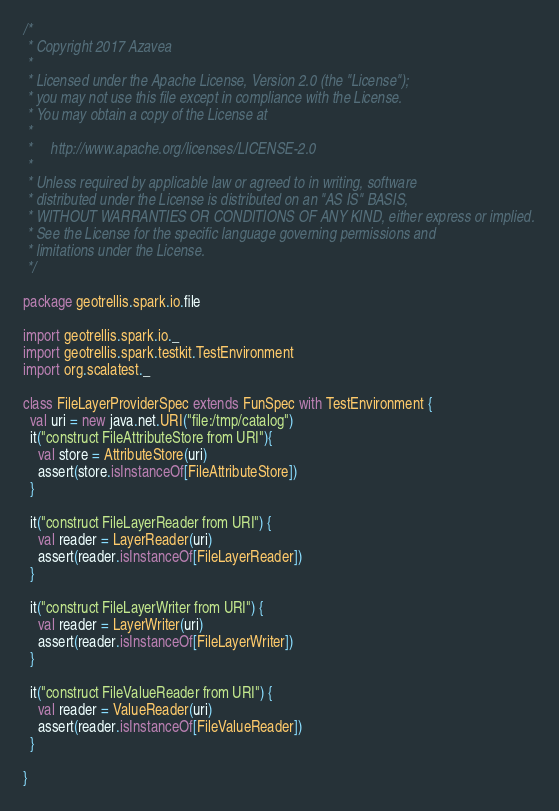<code> <loc_0><loc_0><loc_500><loc_500><_Scala_>/*
 * Copyright 2017 Azavea
 *
 * Licensed under the Apache License, Version 2.0 (the "License");
 * you may not use this file except in compliance with the License.
 * You may obtain a copy of the License at
 *
 *     http://www.apache.org/licenses/LICENSE-2.0
 *
 * Unless required by applicable law or agreed to in writing, software
 * distributed under the License is distributed on an "AS IS" BASIS,
 * WITHOUT WARRANTIES OR CONDITIONS OF ANY KIND, either express or implied.
 * See the License for the specific language governing permissions and
 * limitations under the License.
 */

package geotrellis.spark.io.file

import geotrellis.spark.io._
import geotrellis.spark.testkit.TestEnvironment
import org.scalatest._

class FileLayerProviderSpec extends FunSpec with TestEnvironment {
  val uri = new java.net.URI("file:/tmp/catalog")
  it("construct FileAttributeStore from URI"){
    val store = AttributeStore(uri)
    assert(store.isInstanceOf[FileAttributeStore])
  }

  it("construct FileLayerReader from URI") {
    val reader = LayerReader(uri)
    assert(reader.isInstanceOf[FileLayerReader])
  }

  it("construct FileLayerWriter from URI") {
    val reader = LayerWriter(uri)
    assert(reader.isInstanceOf[FileLayerWriter])
  }

  it("construct FileValueReader from URI") {
    val reader = ValueReader(uri)
    assert(reader.isInstanceOf[FileValueReader])
  }

}
</code> 